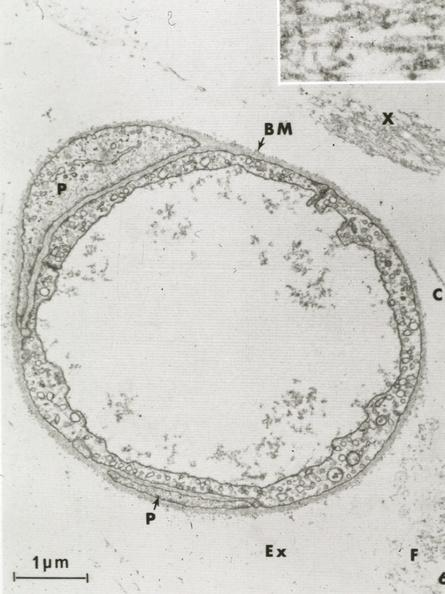s lymphangiomatosis present?
Answer the question using a single word or phrase. No 